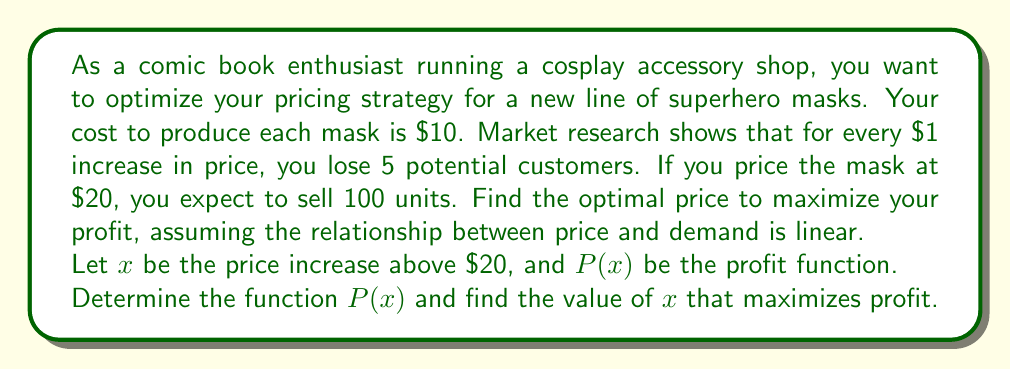What is the answer to this math problem? Let's approach this step-by-step:

1) First, let's define our variables:
   $x$ = price increase above $20
   $p = 20 + x$ = actual price of the mask
   $q$ = quantity sold

2) We know that at $20, we sell 100 units. For every $1 increase, we lose 5 customers. So we can express quantity as:
   $q = 100 - 5x$

3) Our profit function will be: Revenue - Cost
   $P(x) = pq - 10q$
   $P(x) = (20+x)(100-5x) - 10(100-5x)$

4) Let's expand this:
   $P(x) = 2000 + 100x - 100x - 5x^2 - 1000 + 50x$
   $P(x) = 1000 + 50x - 5x^2$

5) To find the maximum, we need to find where the derivative equals zero:
   $P'(x) = 50 - 10x$
   $50 - 10x = 0$
   $10x = 50$
   $x = 5$

6) To confirm this is a maximum, we can check the second derivative:
   $P''(x) = -10$, which is negative, confirming a maximum.

7) Therefore, the optimal price increase is $5, making the optimal price $25.

8) We can calculate the maximum profit:
   $P(5) = 1000 + 50(5) - 5(5^2) = 1125$
Answer: The optimal price to maximize profit is $25, resulting in a maximum profit of $1125. 